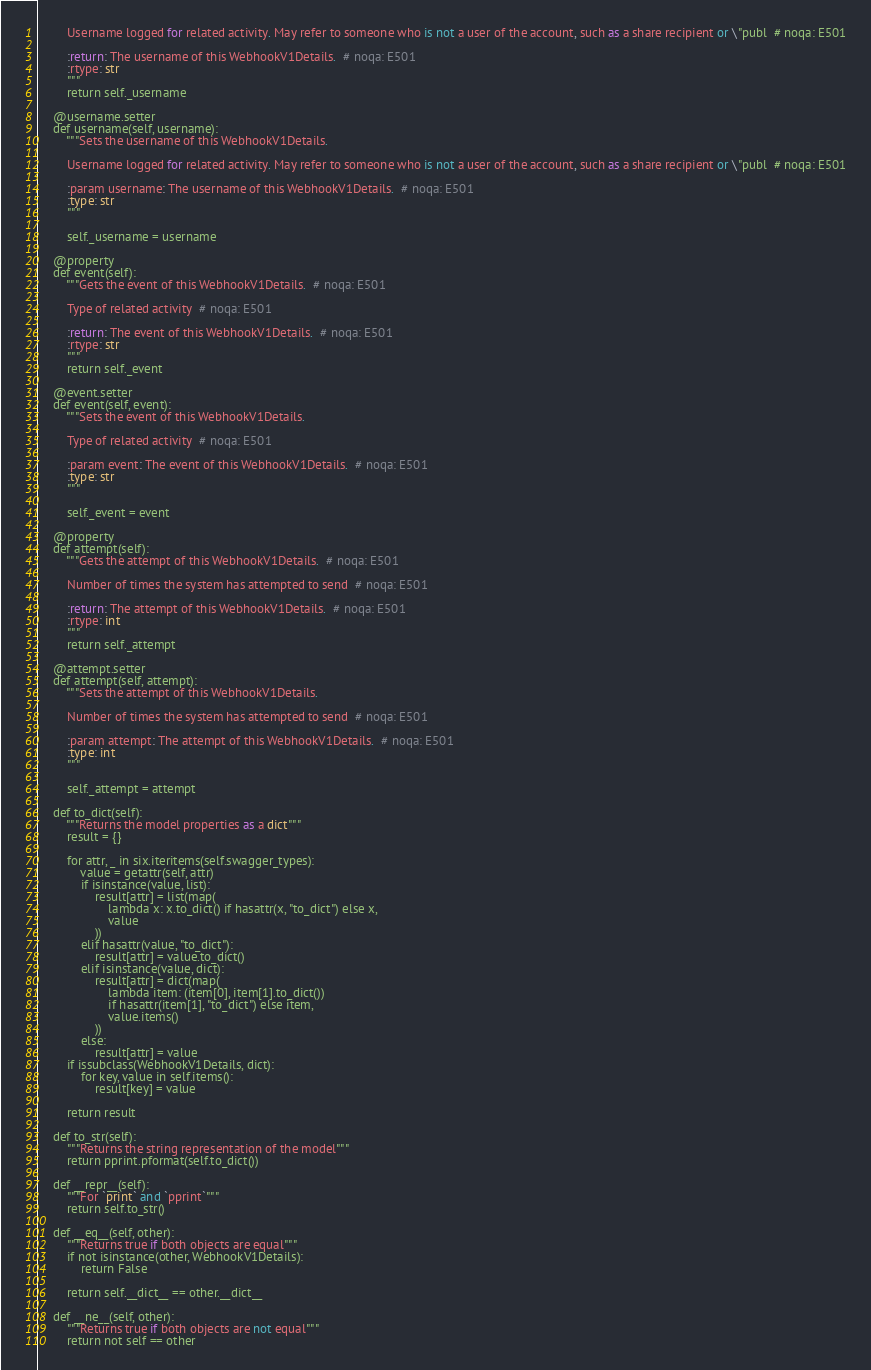<code> <loc_0><loc_0><loc_500><loc_500><_Python_>
        Username logged for related activity. May refer to someone who is not a user of the account, such as a share recipient or \"publ  # noqa: E501

        :return: The username of this WebhookV1Details.  # noqa: E501
        :rtype: str
        """
        return self._username

    @username.setter
    def username(self, username):
        """Sets the username of this WebhookV1Details.

        Username logged for related activity. May refer to someone who is not a user of the account, such as a share recipient or \"publ  # noqa: E501

        :param username: The username of this WebhookV1Details.  # noqa: E501
        :type: str
        """

        self._username = username

    @property
    def event(self):
        """Gets the event of this WebhookV1Details.  # noqa: E501

        Type of related activity  # noqa: E501

        :return: The event of this WebhookV1Details.  # noqa: E501
        :rtype: str
        """
        return self._event

    @event.setter
    def event(self, event):
        """Sets the event of this WebhookV1Details.

        Type of related activity  # noqa: E501

        :param event: The event of this WebhookV1Details.  # noqa: E501
        :type: str
        """

        self._event = event

    @property
    def attempt(self):
        """Gets the attempt of this WebhookV1Details.  # noqa: E501

        Number of times the system has attempted to send  # noqa: E501

        :return: The attempt of this WebhookV1Details.  # noqa: E501
        :rtype: int
        """
        return self._attempt

    @attempt.setter
    def attempt(self, attempt):
        """Sets the attempt of this WebhookV1Details.

        Number of times the system has attempted to send  # noqa: E501

        :param attempt: The attempt of this WebhookV1Details.  # noqa: E501
        :type: int
        """

        self._attempt = attempt

    def to_dict(self):
        """Returns the model properties as a dict"""
        result = {}

        for attr, _ in six.iteritems(self.swagger_types):
            value = getattr(self, attr)
            if isinstance(value, list):
                result[attr] = list(map(
                    lambda x: x.to_dict() if hasattr(x, "to_dict") else x,
                    value
                ))
            elif hasattr(value, "to_dict"):
                result[attr] = value.to_dict()
            elif isinstance(value, dict):
                result[attr] = dict(map(
                    lambda item: (item[0], item[1].to_dict())
                    if hasattr(item[1], "to_dict") else item,
                    value.items()
                ))
            else:
                result[attr] = value
        if issubclass(WebhookV1Details, dict):
            for key, value in self.items():
                result[key] = value

        return result

    def to_str(self):
        """Returns the string representation of the model"""
        return pprint.pformat(self.to_dict())

    def __repr__(self):
        """For `print` and `pprint`"""
        return self.to_str()

    def __eq__(self, other):
        """Returns true if both objects are equal"""
        if not isinstance(other, WebhookV1Details):
            return False

        return self.__dict__ == other.__dict__

    def __ne__(self, other):
        """Returns true if both objects are not equal"""
        return not self == other
</code> 